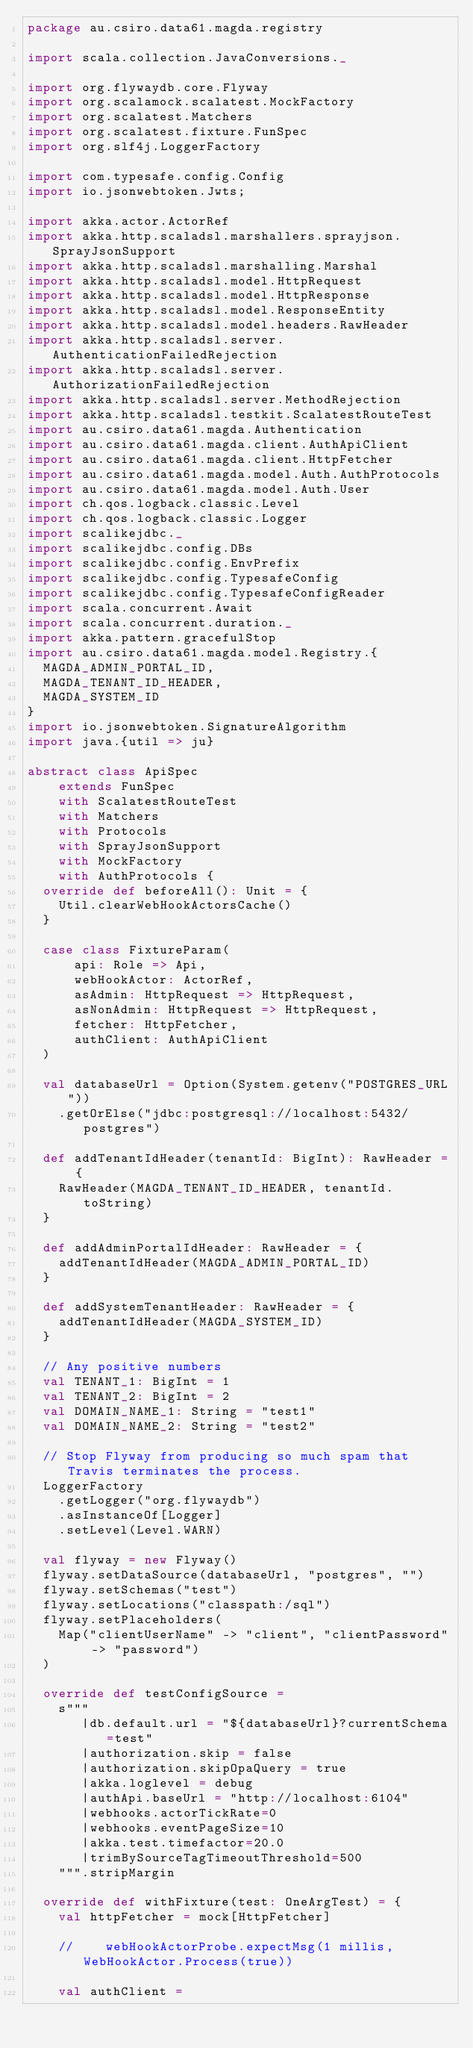Convert code to text. <code><loc_0><loc_0><loc_500><loc_500><_Scala_>package au.csiro.data61.magda.registry

import scala.collection.JavaConversions._

import org.flywaydb.core.Flyway
import org.scalamock.scalatest.MockFactory
import org.scalatest.Matchers
import org.scalatest.fixture.FunSpec
import org.slf4j.LoggerFactory

import com.typesafe.config.Config
import io.jsonwebtoken.Jwts;

import akka.actor.ActorRef
import akka.http.scaladsl.marshallers.sprayjson.SprayJsonSupport
import akka.http.scaladsl.marshalling.Marshal
import akka.http.scaladsl.model.HttpRequest
import akka.http.scaladsl.model.HttpResponse
import akka.http.scaladsl.model.ResponseEntity
import akka.http.scaladsl.model.headers.RawHeader
import akka.http.scaladsl.server.AuthenticationFailedRejection
import akka.http.scaladsl.server.AuthorizationFailedRejection
import akka.http.scaladsl.server.MethodRejection
import akka.http.scaladsl.testkit.ScalatestRouteTest
import au.csiro.data61.magda.Authentication
import au.csiro.data61.magda.client.AuthApiClient
import au.csiro.data61.magda.client.HttpFetcher
import au.csiro.data61.magda.model.Auth.AuthProtocols
import au.csiro.data61.magda.model.Auth.User
import ch.qos.logback.classic.Level
import ch.qos.logback.classic.Logger
import scalikejdbc._
import scalikejdbc.config.DBs
import scalikejdbc.config.EnvPrefix
import scalikejdbc.config.TypesafeConfig
import scalikejdbc.config.TypesafeConfigReader
import scala.concurrent.Await
import scala.concurrent.duration._
import akka.pattern.gracefulStop
import au.csiro.data61.magda.model.Registry.{
  MAGDA_ADMIN_PORTAL_ID,
  MAGDA_TENANT_ID_HEADER,
  MAGDA_SYSTEM_ID
}
import io.jsonwebtoken.SignatureAlgorithm
import java.{util => ju}

abstract class ApiSpec
    extends FunSpec
    with ScalatestRouteTest
    with Matchers
    with Protocols
    with SprayJsonSupport
    with MockFactory
    with AuthProtocols {
  override def beforeAll(): Unit = {
    Util.clearWebHookActorsCache()
  }

  case class FixtureParam(
      api: Role => Api,
      webHookActor: ActorRef,
      asAdmin: HttpRequest => HttpRequest,
      asNonAdmin: HttpRequest => HttpRequest,
      fetcher: HttpFetcher,
      authClient: AuthApiClient
  )

  val databaseUrl = Option(System.getenv("POSTGRES_URL"))
    .getOrElse("jdbc:postgresql://localhost:5432/postgres")

  def addTenantIdHeader(tenantId: BigInt): RawHeader = {
    RawHeader(MAGDA_TENANT_ID_HEADER, tenantId.toString)
  }

  def addAdminPortalIdHeader: RawHeader = {
    addTenantIdHeader(MAGDA_ADMIN_PORTAL_ID)
  }

  def addSystemTenantHeader: RawHeader = {
    addTenantIdHeader(MAGDA_SYSTEM_ID)
  }

  // Any positive numbers
  val TENANT_1: BigInt = 1
  val TENANT_2: BigInt = 2
  val DOMAIN_NAME_1: String = "test1"
  val DOMAIN_NAME_2: String = "test2"

  // Stop Flyway from producing so much spam that Travis terminates the process.
  LoggerFactory
    .getLogger("org.flywaydb")
    .asInstanceOf[Logger]
    .setLevel(Level.WARN)

  val flyway = new Flyway()
  flyway.setDataSource(databaseUrl, "postgres", "")
  flyway.setSchemas("test")
  flyway.setLocations("classpath:/sql")
  flyway.setPlaceholders(
    Map("clientUserName" -> "client", "clientPassword" -> "password")
  )

  override def testConfigSource =
    s"""
       |db.default.url = "${databaseUrl}?currentSchema=test"
       |authorization.skip = false
       |authorization.skipOpaQuery = true
       |akka.loglevel = debug
       |authApi.baseUrl = "http://localhost:6104"
       |webhooks.actorTickRate=0
       |webhooks.eventPageSize=10
       |akka.test.timefactor=20.0
       |trimBySourceTagTimeoutThreshold=500
    """.stripMargin

  override def withFixture(test: OneArgTest) = {
    val httpFetcher = mock[HttpFetcher]

    //    webHookActorProbe.expectMsg(1 millis, WebHookActor.Process(true))

    val authClient =</code> 